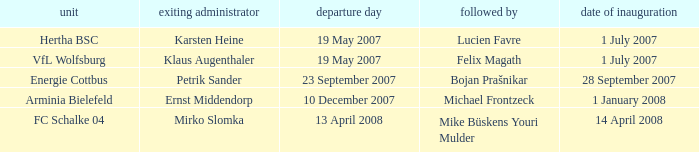When is the appointment date for outgoing manager Petrik Sander? 28 September 2007. 